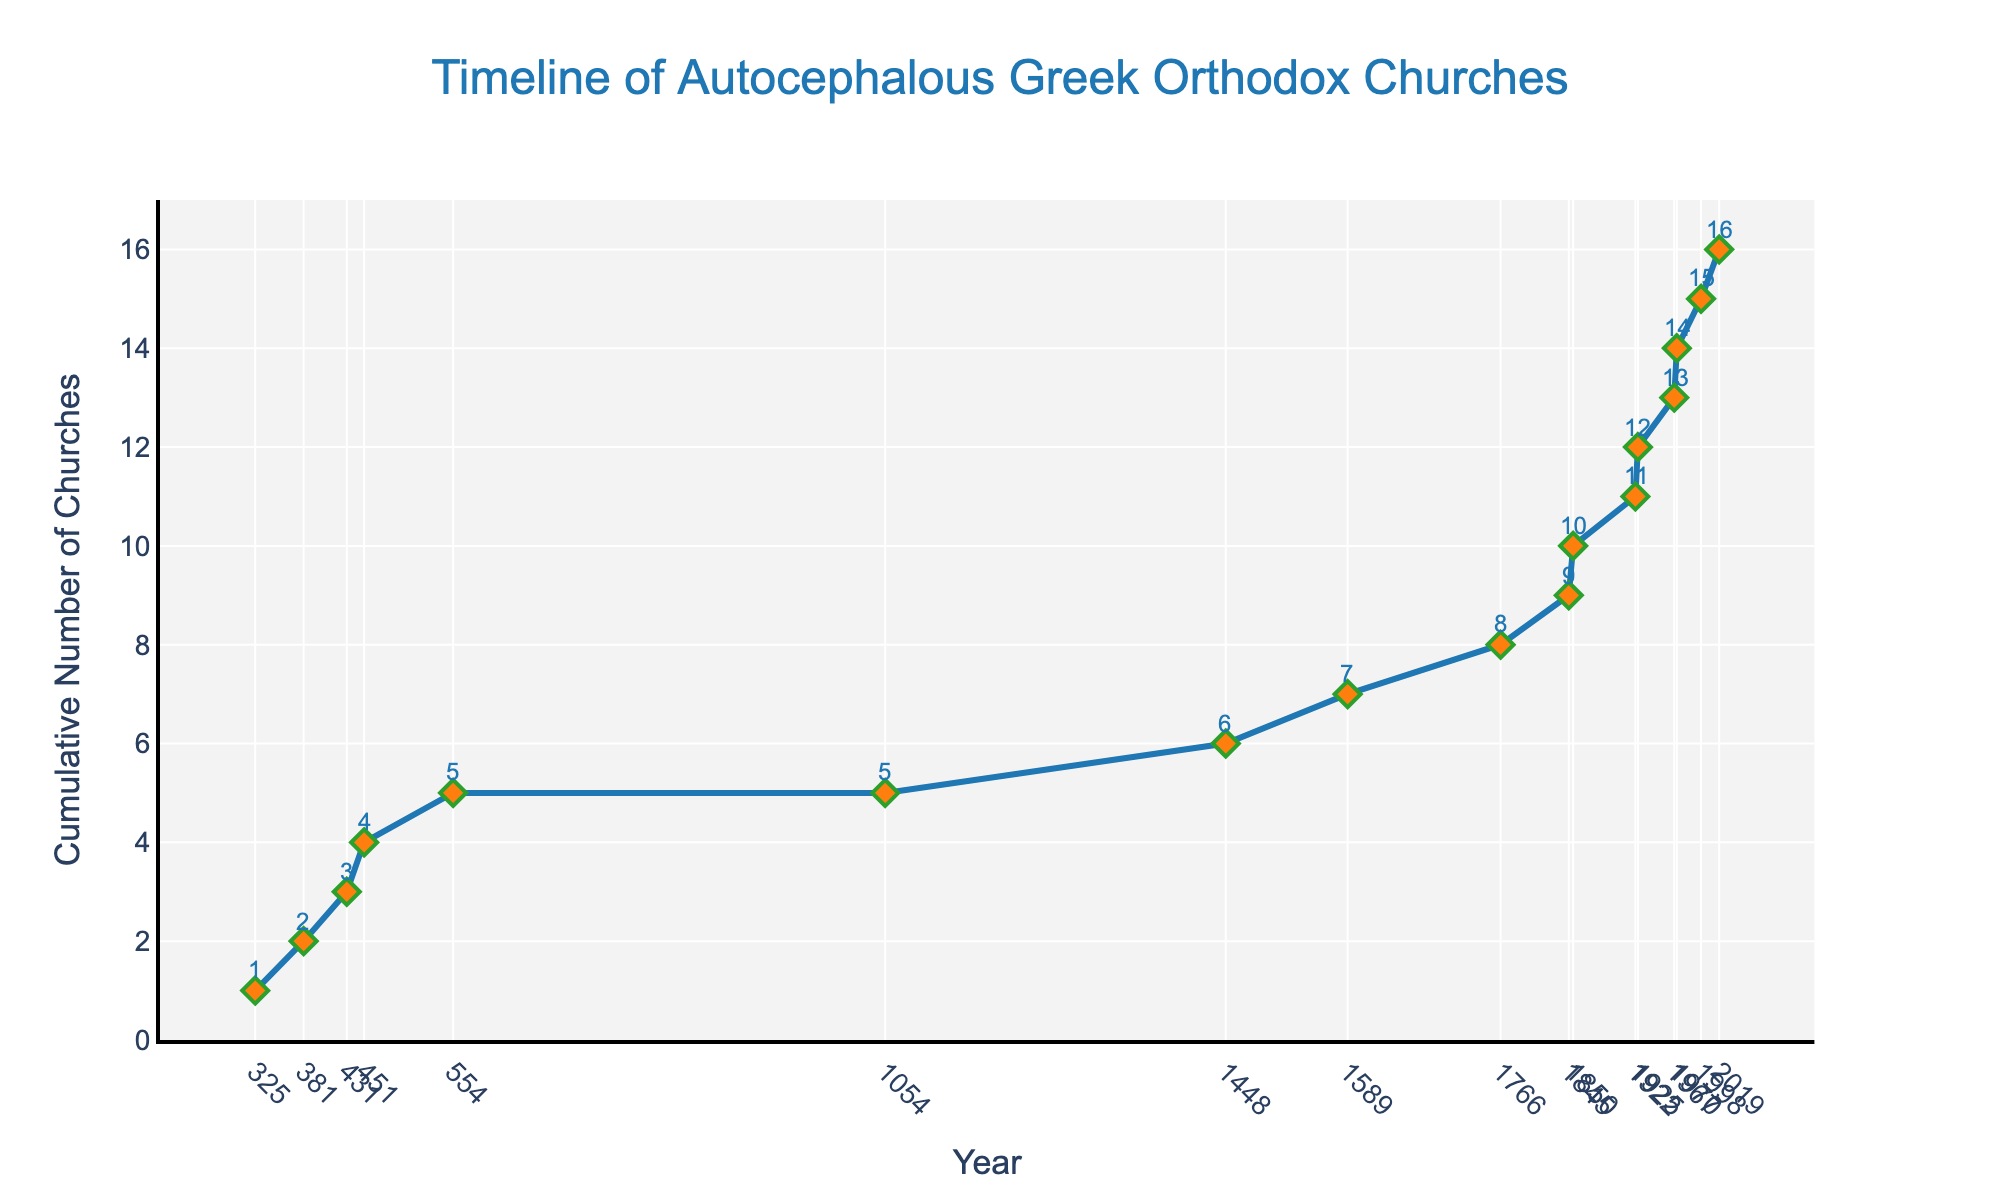What is the total number of autocephalous Greek Orthodox churches established by the year 1448? By the year 1448, the cumulative number of autocephalous Greek Orthodox churches is shown on the y-axis at the marker where the x-axis is 1448.
Answer: 6 How many new autocephalous Greek Orthodox churches were established between the years 431 and 451? Find the cumulative number of churches at 451 (4), then subtract the cumulative number at 431 (3): 4 - 3 = 1.
Answer: 1 Which year saw the most recent addition to the number of autocephalous Greek Orthodox churches in the data provided? Look at the x-axis and find the latest year in the dataset, which is 2019. The y-marker at 2019 confirms this as the most recent year.
Answer: 2019 By how much did the number of autocephalous Greek Orthodox churches increase between 1054 and 1766? Find the cumulative number of churches at 1766 (8), then subtract the cumulative number at 1054 (5): 8 - 5 = 3.
Answer: 3 What is the rate of increase in the number of autocephalous Greek Orthodox churches from 1845 to 1850? Calculate the increase in churches (10 - 9 = 1) and divide by the number of years (5): 1/5 = 0.2 churches per year.
Answer: 0.2 churches per year In which period did the cumulative number of autocephalous Greek Orthodox churches remain static? Identify the flat sections on the line graph; from 554 to 1054, the cumulative number remains at 5.
Answer: 554 to 1054 Which year marks the first significant increase in the number of autocephalous Greek Orthodox churches? The first noticeable increase occurs from 325 (1) to 381 (2).
Answer: 381 How many years did it take for the number of autocephalous Greek Orthodox churches to grow from 6 to 7? Look at the years when this increase happens: from 1448 (6) to 1589 (7), which is 1589 - 1448 = 141 years.
Answer: 141 years What's the average number of autocephalous Greek Orthodox churches added per century between 431 and 1054? Between 431 (3 churches) and 1054 (5 churches), only 2 churches were added over 623 years. The average per 100 years is: (2/623) * 100 ≈ 0.32 churches per century.
Answer: 0.32 churches per century 